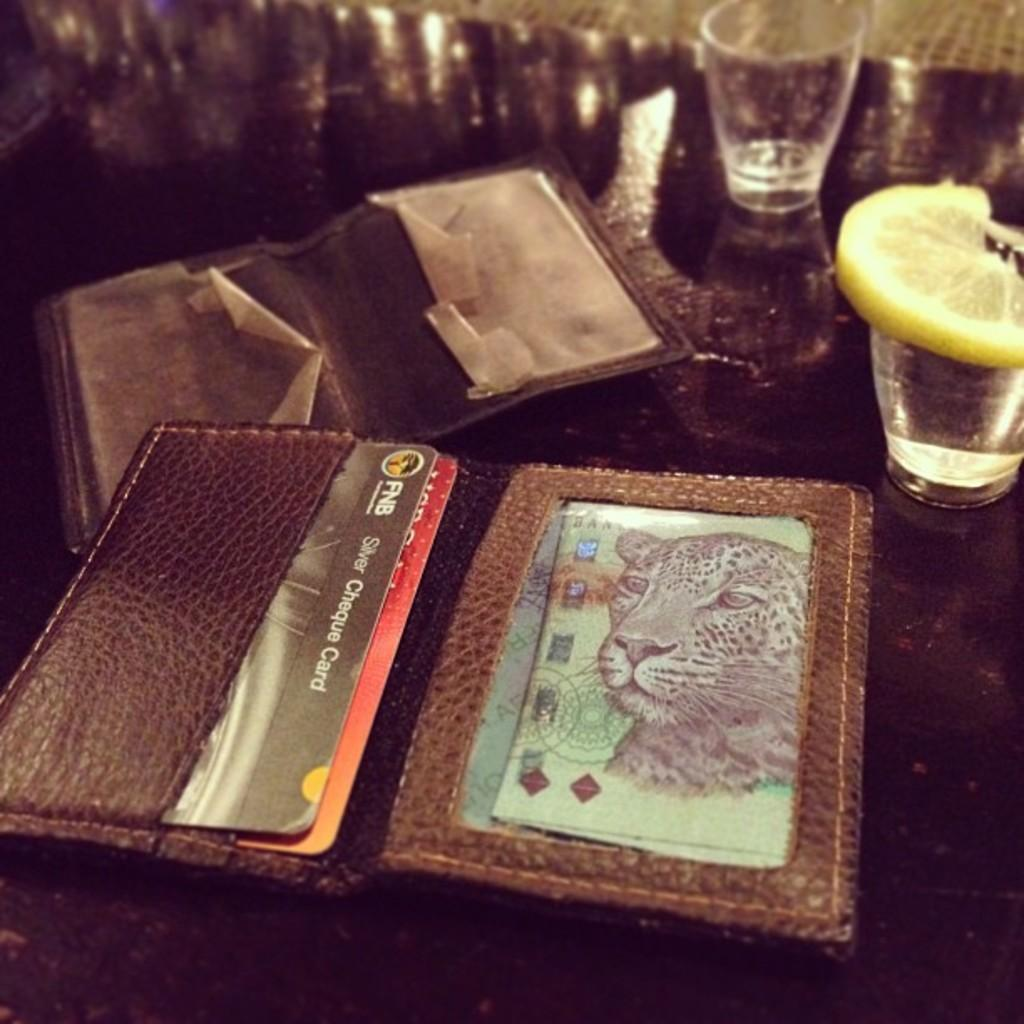<image>
Create a compact narrative representing the image presented. A wallet filled with cards including a silver cheque card. 